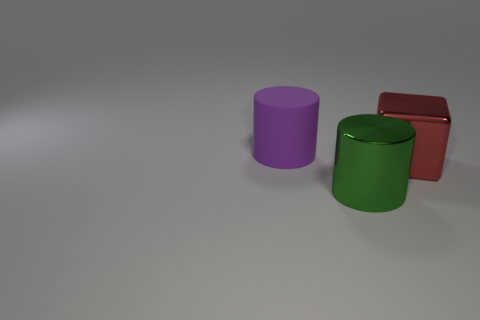The other large thing that is the same material as the green object is what color?
Provide a short and direct response. Red. Is the number of rubber cylinders greater than the number of cyan cubes?
Your answer should be very brief. Yes. Are there any small brown objects?
Keep it short and to the point. No. What shape is the thing that is to the right of the cylinder in front of the big purple rubber cylinder?
Make the answer very short. Cube. How many things are either purple matte things or big things that are to the right of the big green thing?
Ensure brevity in your answer.  2. The cylinder that is on the right side of the cylinder that is behind the large cylinder on the right side of the big rubber thing is what color?
Keep it short and to the point. Green. There is another large thing that is the same shape as the matte thing; what is its material?
Your response must be concise. Metal. The large matte object has what color?
Provide a succinct answer. Purple. Does the metal cylinder have the same color as the metal block?
Your answer should be compact. No. How many rubber things are small blue cylinders or green cylinders?
Your response must be concise. 0. 